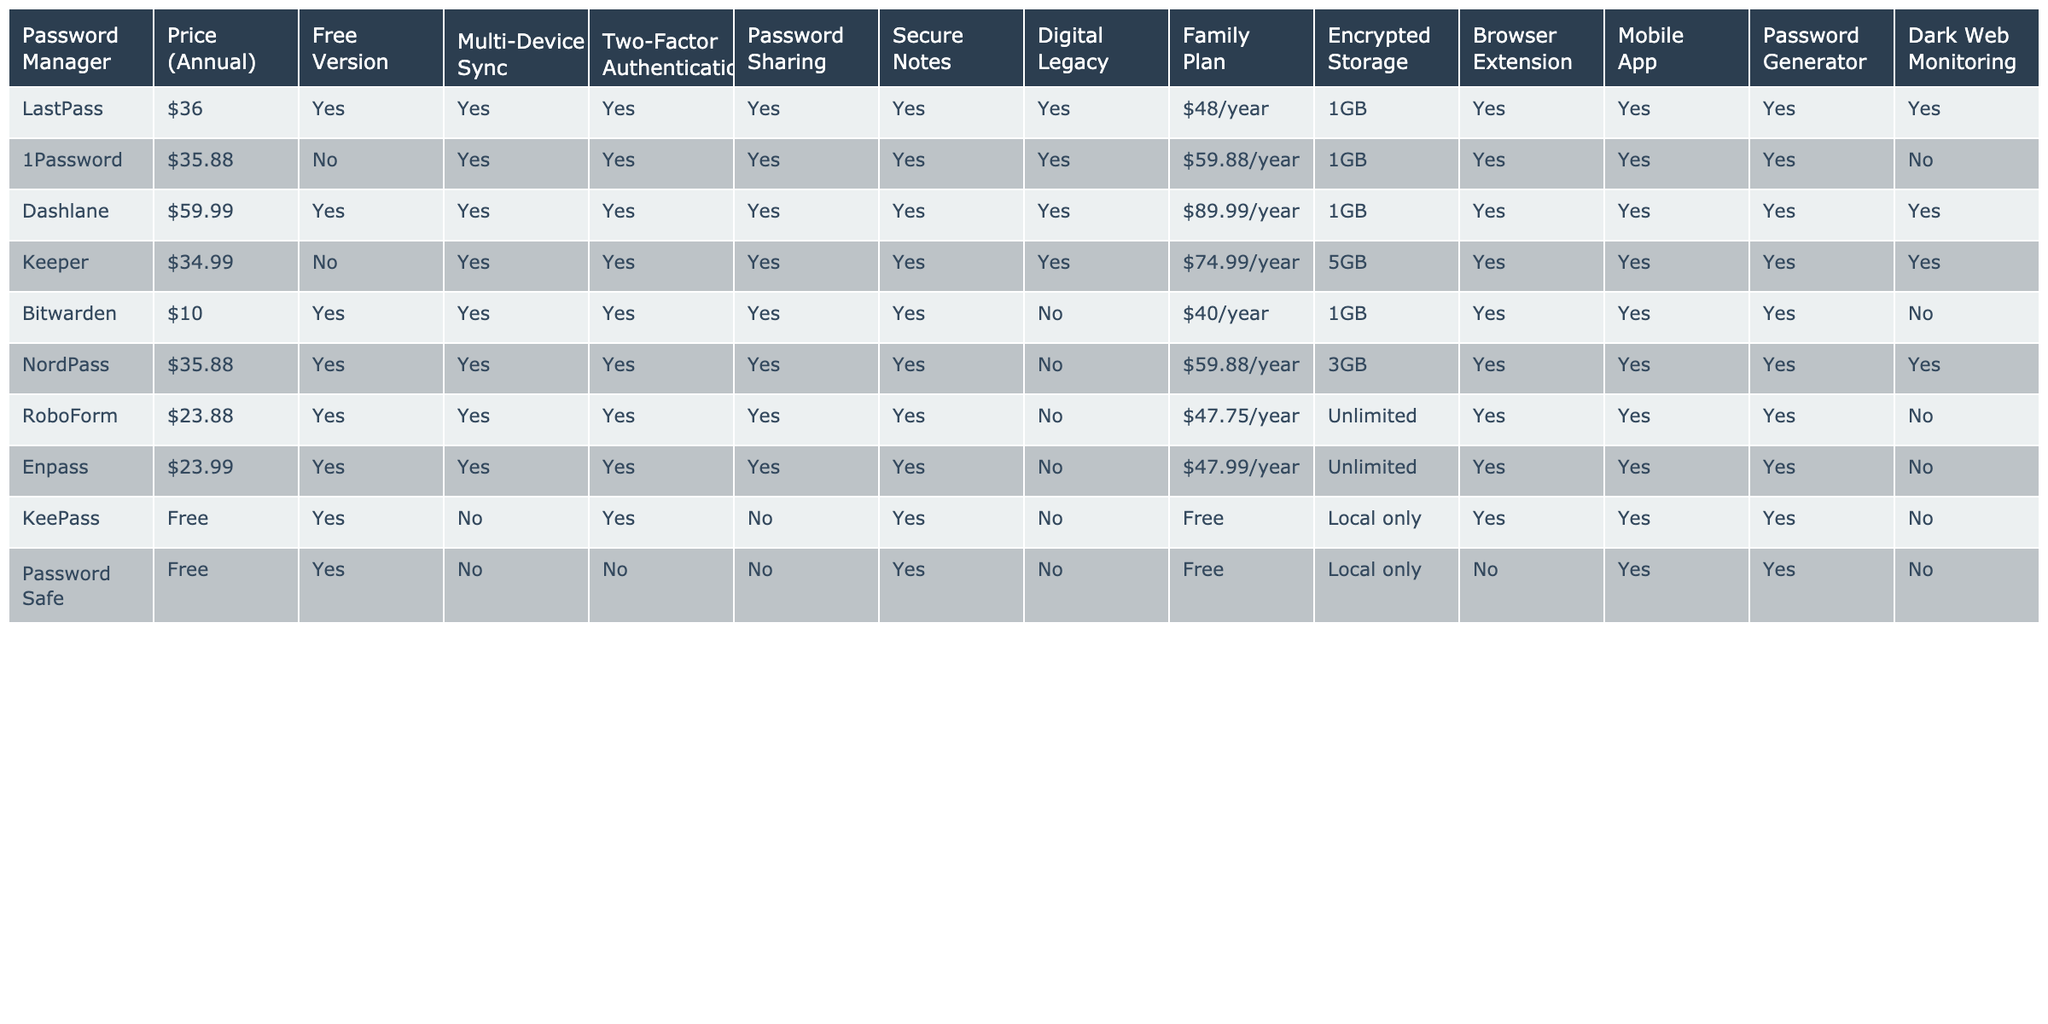What is the price of Dashlane for an annual subscription? According to the table, the annual price for Dashlane is listed as $59.99.
Answer: $59.99 Does Bitwarden have a free version? The table indicates that Bitwarden does have a free version available.
Answer: Yes Which password manager offers the highest storage capacity? By checking the table, Keeper offers 5GB of encrypted storage, which is the highest compared to others.
Answer: Keeper with 5GB How much is the family plan for LastPass? The table states that the family plan for LastPass costs $48 per year.
Answer: $48/year Is two-factor authentication available for all password managers in the table? Upon reviewing the data, not all password managers provide two-factor authentication; KeePass and Password Safe do not offer this feature.
Answer: No What features do both 1Password and Dashlane have in common? Both password managers offer Multi-Device Sync, Two-Factor Authentication, Password Sharing, Secure Notes, and Digital Legacy, as per the features listed in the table.
Answer: Multi-Device Sync, Two-Factor Authentication, Password Sharing, Secure Notes, Digital Legacy Calculate the average price of the paid password managers (excluding free options). The paid password managers are LastPass ($36), 1Password ($35.88), Dashlane ($59.99), Keeper ($34.99), NordPass ($35.88), RoboForm ($23.88), Enpass ($23.99), and Bitwarden ($10). The total sum is $36 + $35.88 + $59.99 + $34.99 + $35.88 + $23.88 + $23.99 + $10 = $259.49. There are 8 paid options; therefore, the average price is $259.49 / 8 = $32.43.
Answer: $32.43 Which password managers provide a mobile app? Referring to the table, all the password managers listed provide a mobile app except for Password Safe.
Answer: All except Password Safe Is there a password manager that offers a family plan for less than $50? Looking at the table, only Bitwarden offers a family plan for $40, which is less than $50.
Answer: Yes, Bitwarden How many password managers offer password sharing? By examining the table, it can be seen that 7 password managers (LastPass, Dashlane, Keeper, Bitwarden, NordPass, RoboForm, Enpass) provide password sharing features.
Answer: 7 